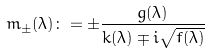<formula> <loc_0><loc_0><loc_500><loc_500>m _ { \pm } ( \lambda ) \colon = \pm \frac { g ( \lambda ) } { k ( \lambda ) \mp i \sqrt { f ( \lambda ) } }</formula> 